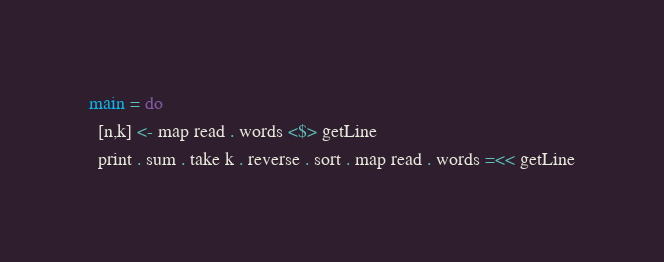Convert code to text. <code><loc_0><loc_0><loc_500><loc_500><_Haskell_>main = do
  [n,k] <- map read . words <$> getLine
  print . sum . take k . reverse . sort . map read . words =<< getLine</code> 